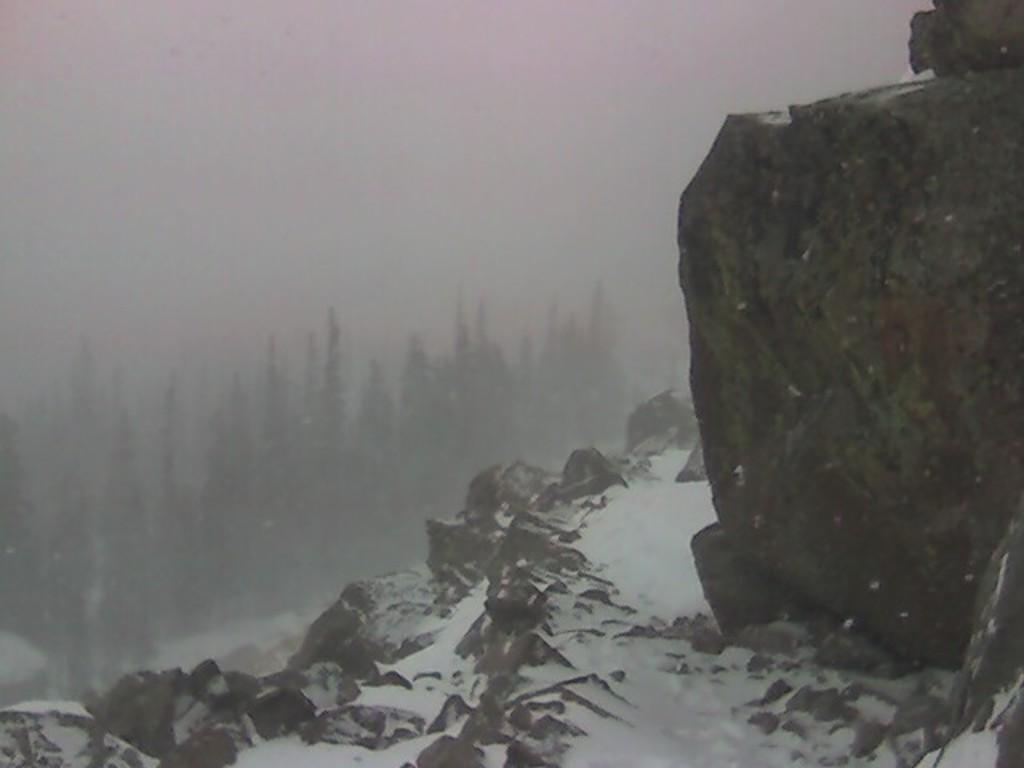Please provide a concise description of this image. Far there are trees. Here we can see snow. 